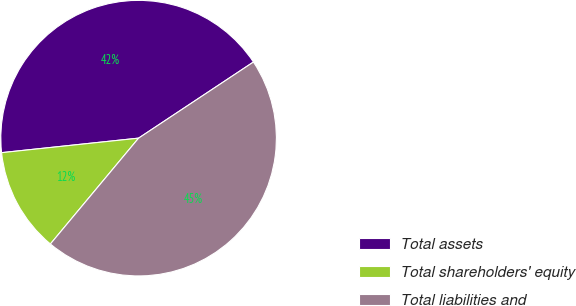<chart> <loc_0><loc_0><loc_500><loc_500><pie_chart><fcel>Total assets<fcel>Total shareholders' equity<fcel>Total liabilities and<nl><fcel>42.36%<fcel>12.26%<fcel>45.37%<nl></chart> 